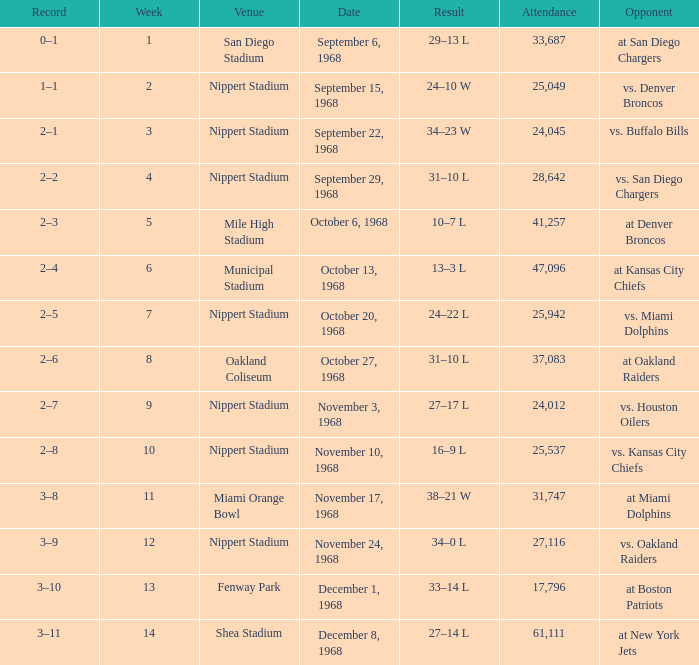What week was the game played at Mile High Stadium? 5.0. 